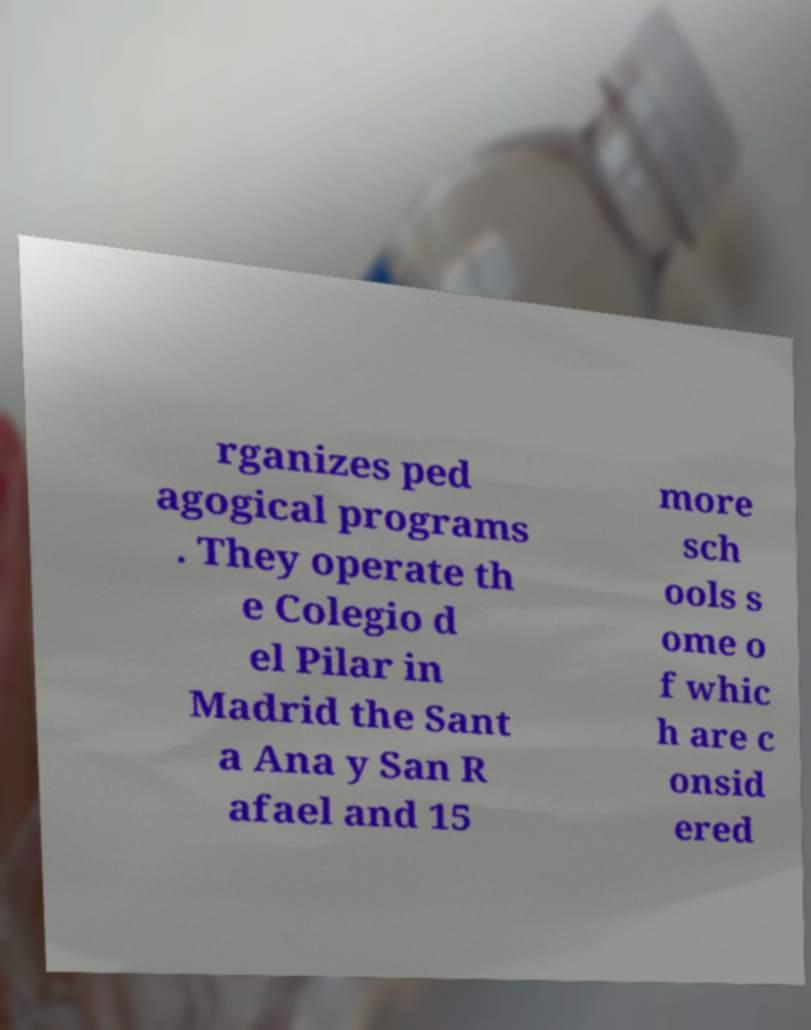I need the written content from this picture converted into text. Can you do that? rganizes ped agogical programs . They operate th e Colegio d el Pilar in Madrid the Sant a Ana y San R afael and 15 more sch ools s ome o f whic h are c onsid ered 